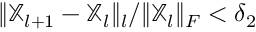<formula> <loc_0><loc_0><loc_500><loc_500>{ \| \mathbb { X } _ { l + 1 } - \mathbb { X } _ { l } \| _ { l } } / { \| \mathbb { X } _ { l } \| _ { F } } < \delta _ { 2 }</formula> 